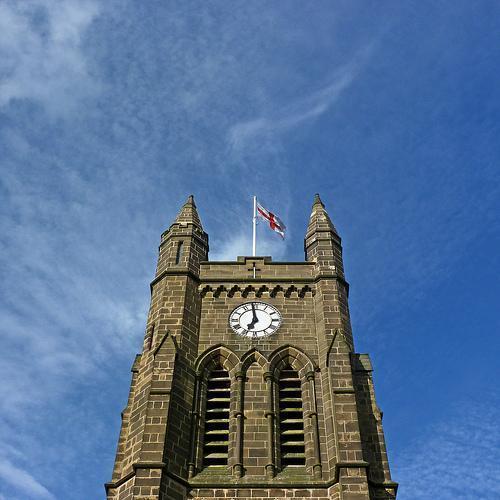How many clocks are there?
Give a very brief answer. 1. 